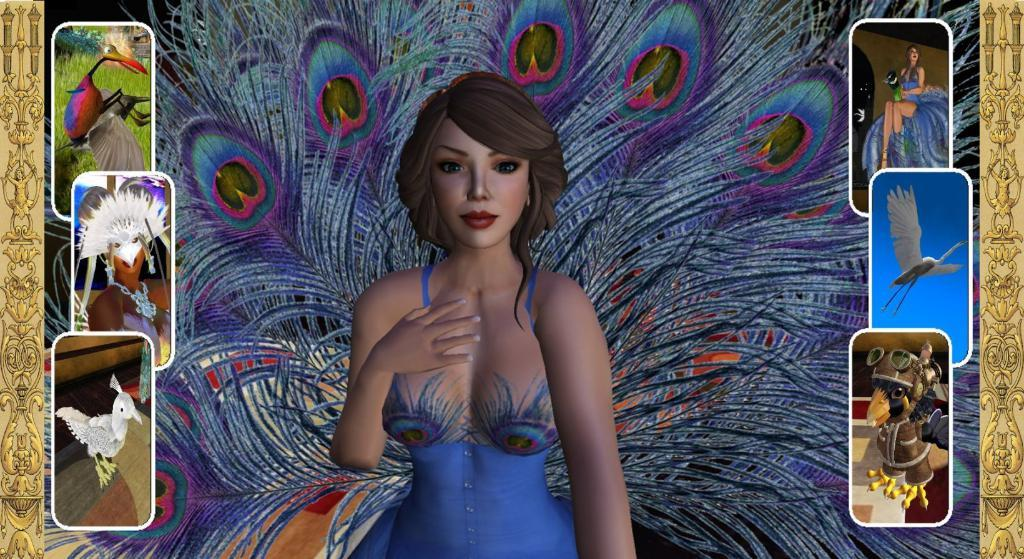What types of subjects are depicted in the images? There are depiction pictures of people and animals in the image. Can you describe the subjects in more detail? The images show various people and animals, but specific details are not provided. How many stamps are visible on the arm of the representative in the image? There is no mention of stamps or representatives in the image, so this question cannot be answered. 